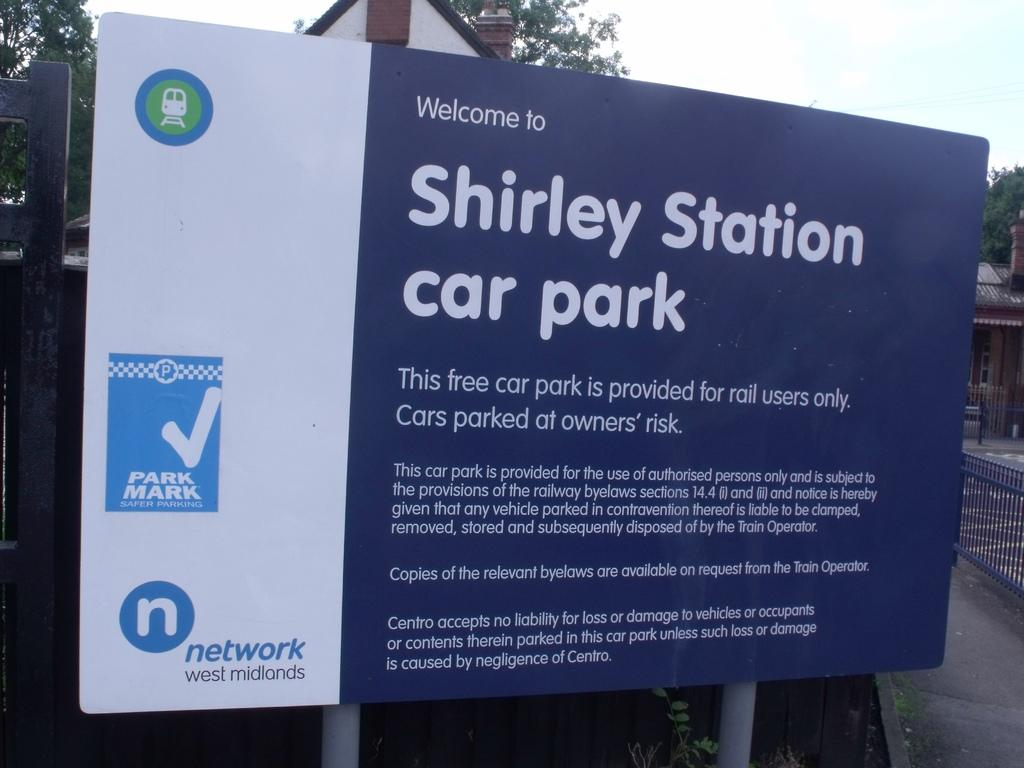Provide a one-sentence caption for the provided image. A large blue and white sign welcomes people to Shirley Station car park. 